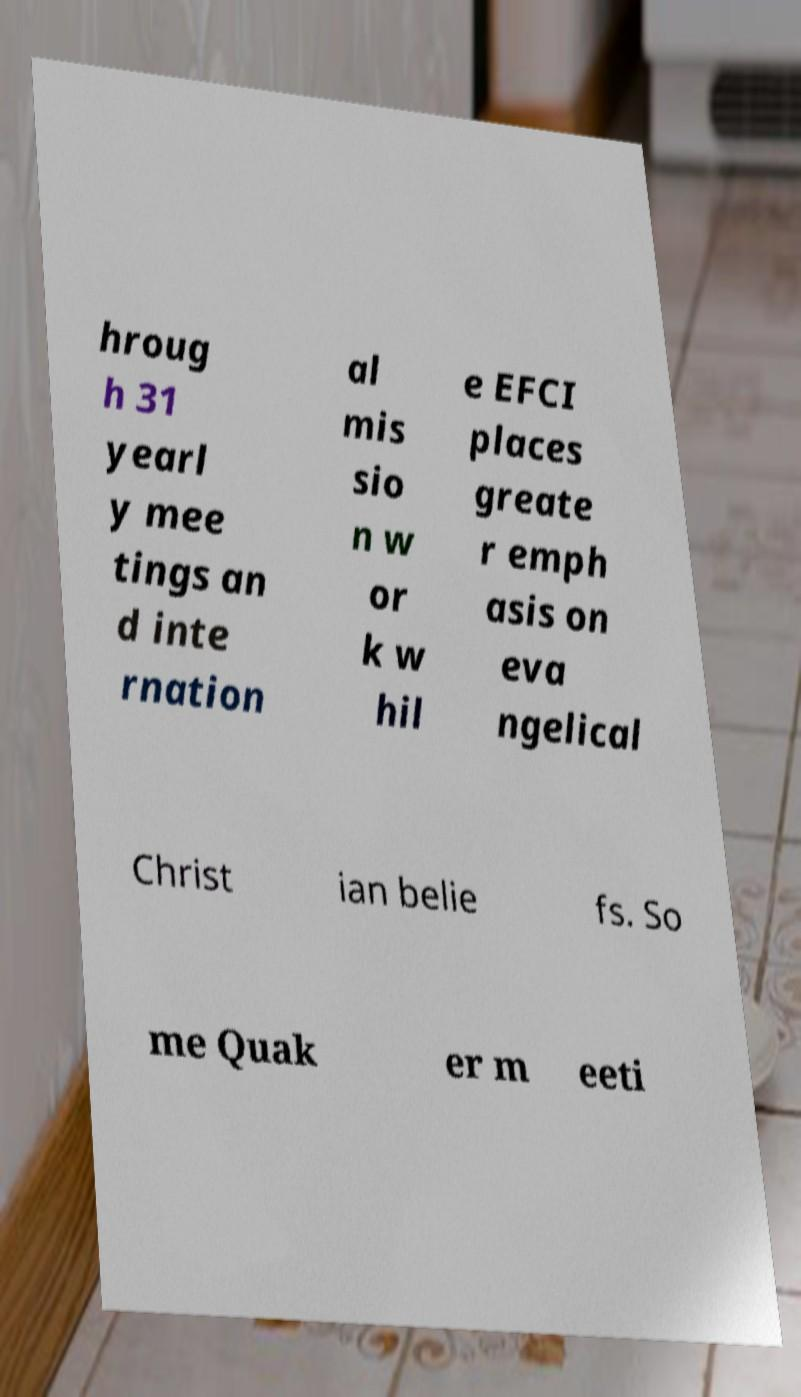Can you accurately transcribe the text from the provided image for me? hroug h 31 yearl y mee tings an d inte rnation al mis sio n w or k w hil e EFCI places greate r emph asis on eva ngelical Christ ian belie fs. So me Quak er m eeti 